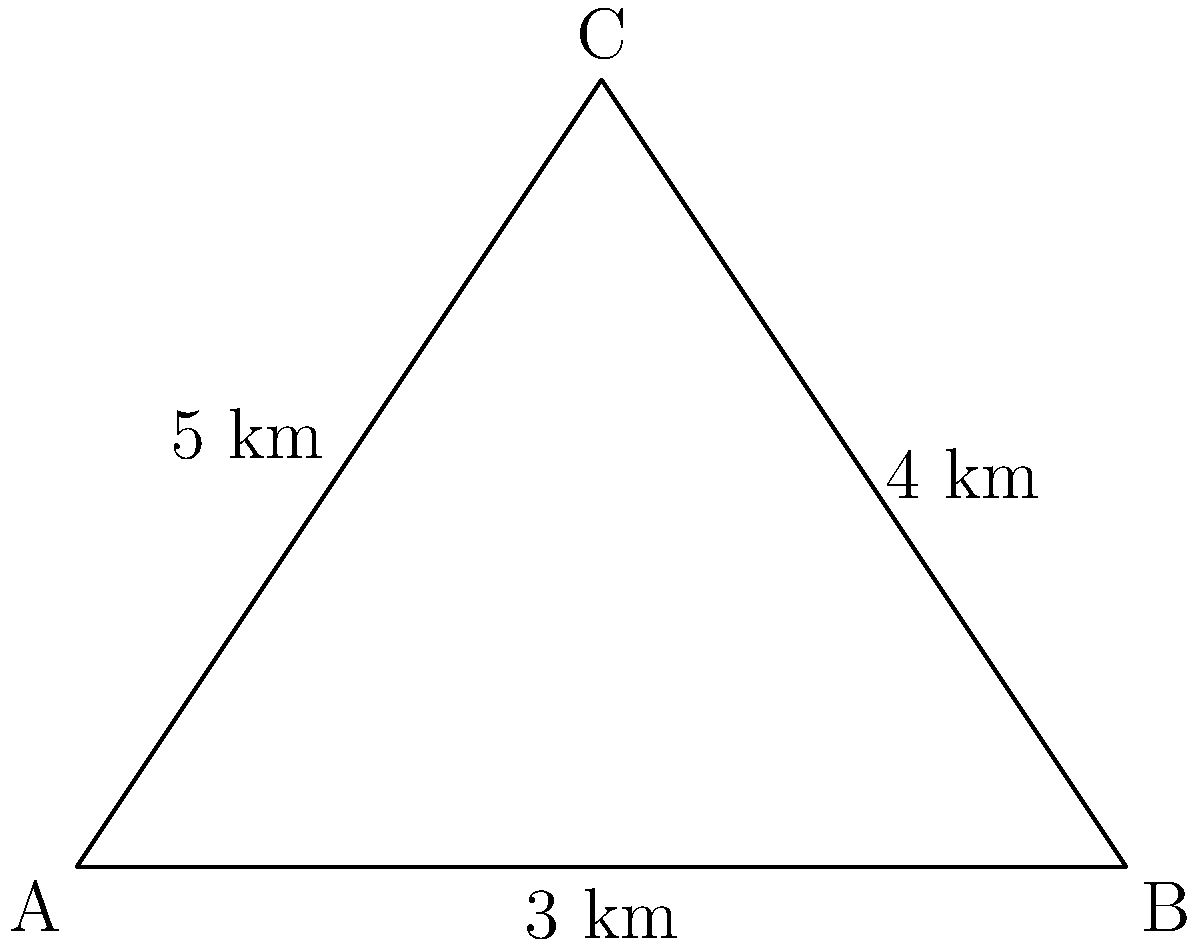Three military units are positioned in a triangular formation. The distances between the units are 3 km, 4 km, and 5 km. What is the area of the triangular region formed by these units? To find the area of the triangular region, we can use Heron's formula. Let's approach this step-by-step:

1) Let's denote the sides of the triangle as $a=3$ km, $b=4$ km, and $c=5$ km.

2) Heron's formula states that the area $A$ of a triangle with sides $a$, $b$, and $c$ is:

   $A = \sqrt{s(s-a)(s-b)(s-c)}$

   where $s$ is the semi-perimeter: $s = \frac{a+b+c}{2}$

3) Calculate the semi-perimeter:
   $s = \frac{3+4+5}{2} = \frac{12}{2} = 6$ km

4) Now, let's substitute these values into Heron's formula:

   $A = \sqrt{6(6-3)(6-4)(6-5)}$
   $= \sqrt{6 \cdot 3 \cdot 2 \cdot 1}$
   $= \sqrt{36}$
   $= 6$ km²

Therefore, the area of the triangular region is 6 square kilometers.
Answer: 6 km² 